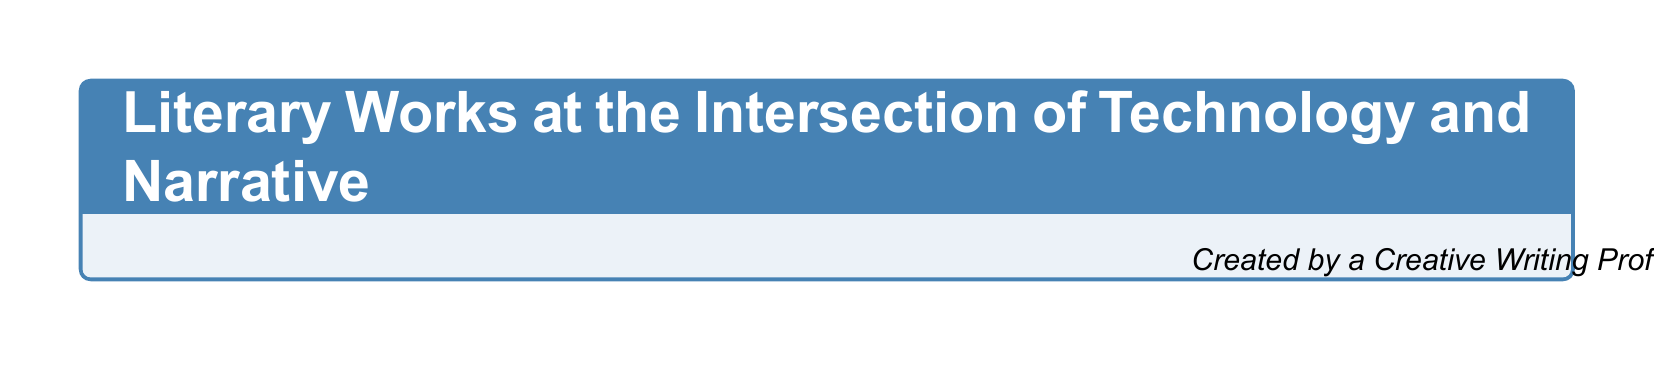What are the two key sections titled in the catalog? The two key sections in the catalog are "Key Technological Themes" and "Narrative Techniques."
Answer: Key Technological Themes, Narrative Techniques Who authored "Neuromancer"? "Neuromancer" is authored by William Gibson, as listed in the catalog.
Answer: William Gibson Which genre includes "The Windup Girl"? "The Windup Girl" is categorized under Science Fiction, according to the organization in the document.
Answer: Science Fiction How many technological themes are listed? The document lists a total of seven technological themes as part of the catalog.
Answer: 7 What narrative technique involves storytelling through different perspectives? The narrative technique that involves storytelling through different perspectives is called "Multiple point-of-view narration."
Answer: Multiple point-of-view narration Which novel addresses the theme of social media and privacy? The novel that addresses the theme of social media and privacy is "The Circle" by Dave Eggers.
Answer: The Circle What is the significance of the "Additional Resources" section? The "Additional Resources" section provides references for further exploration on the intersection of technology and narrative storytelling.
Answer: Further exploration Which genre features works that include autonomous systems? The genre that features works including autonomous systems is Techno-thriller as indicated in the document.
Answer: Techno-thriller 